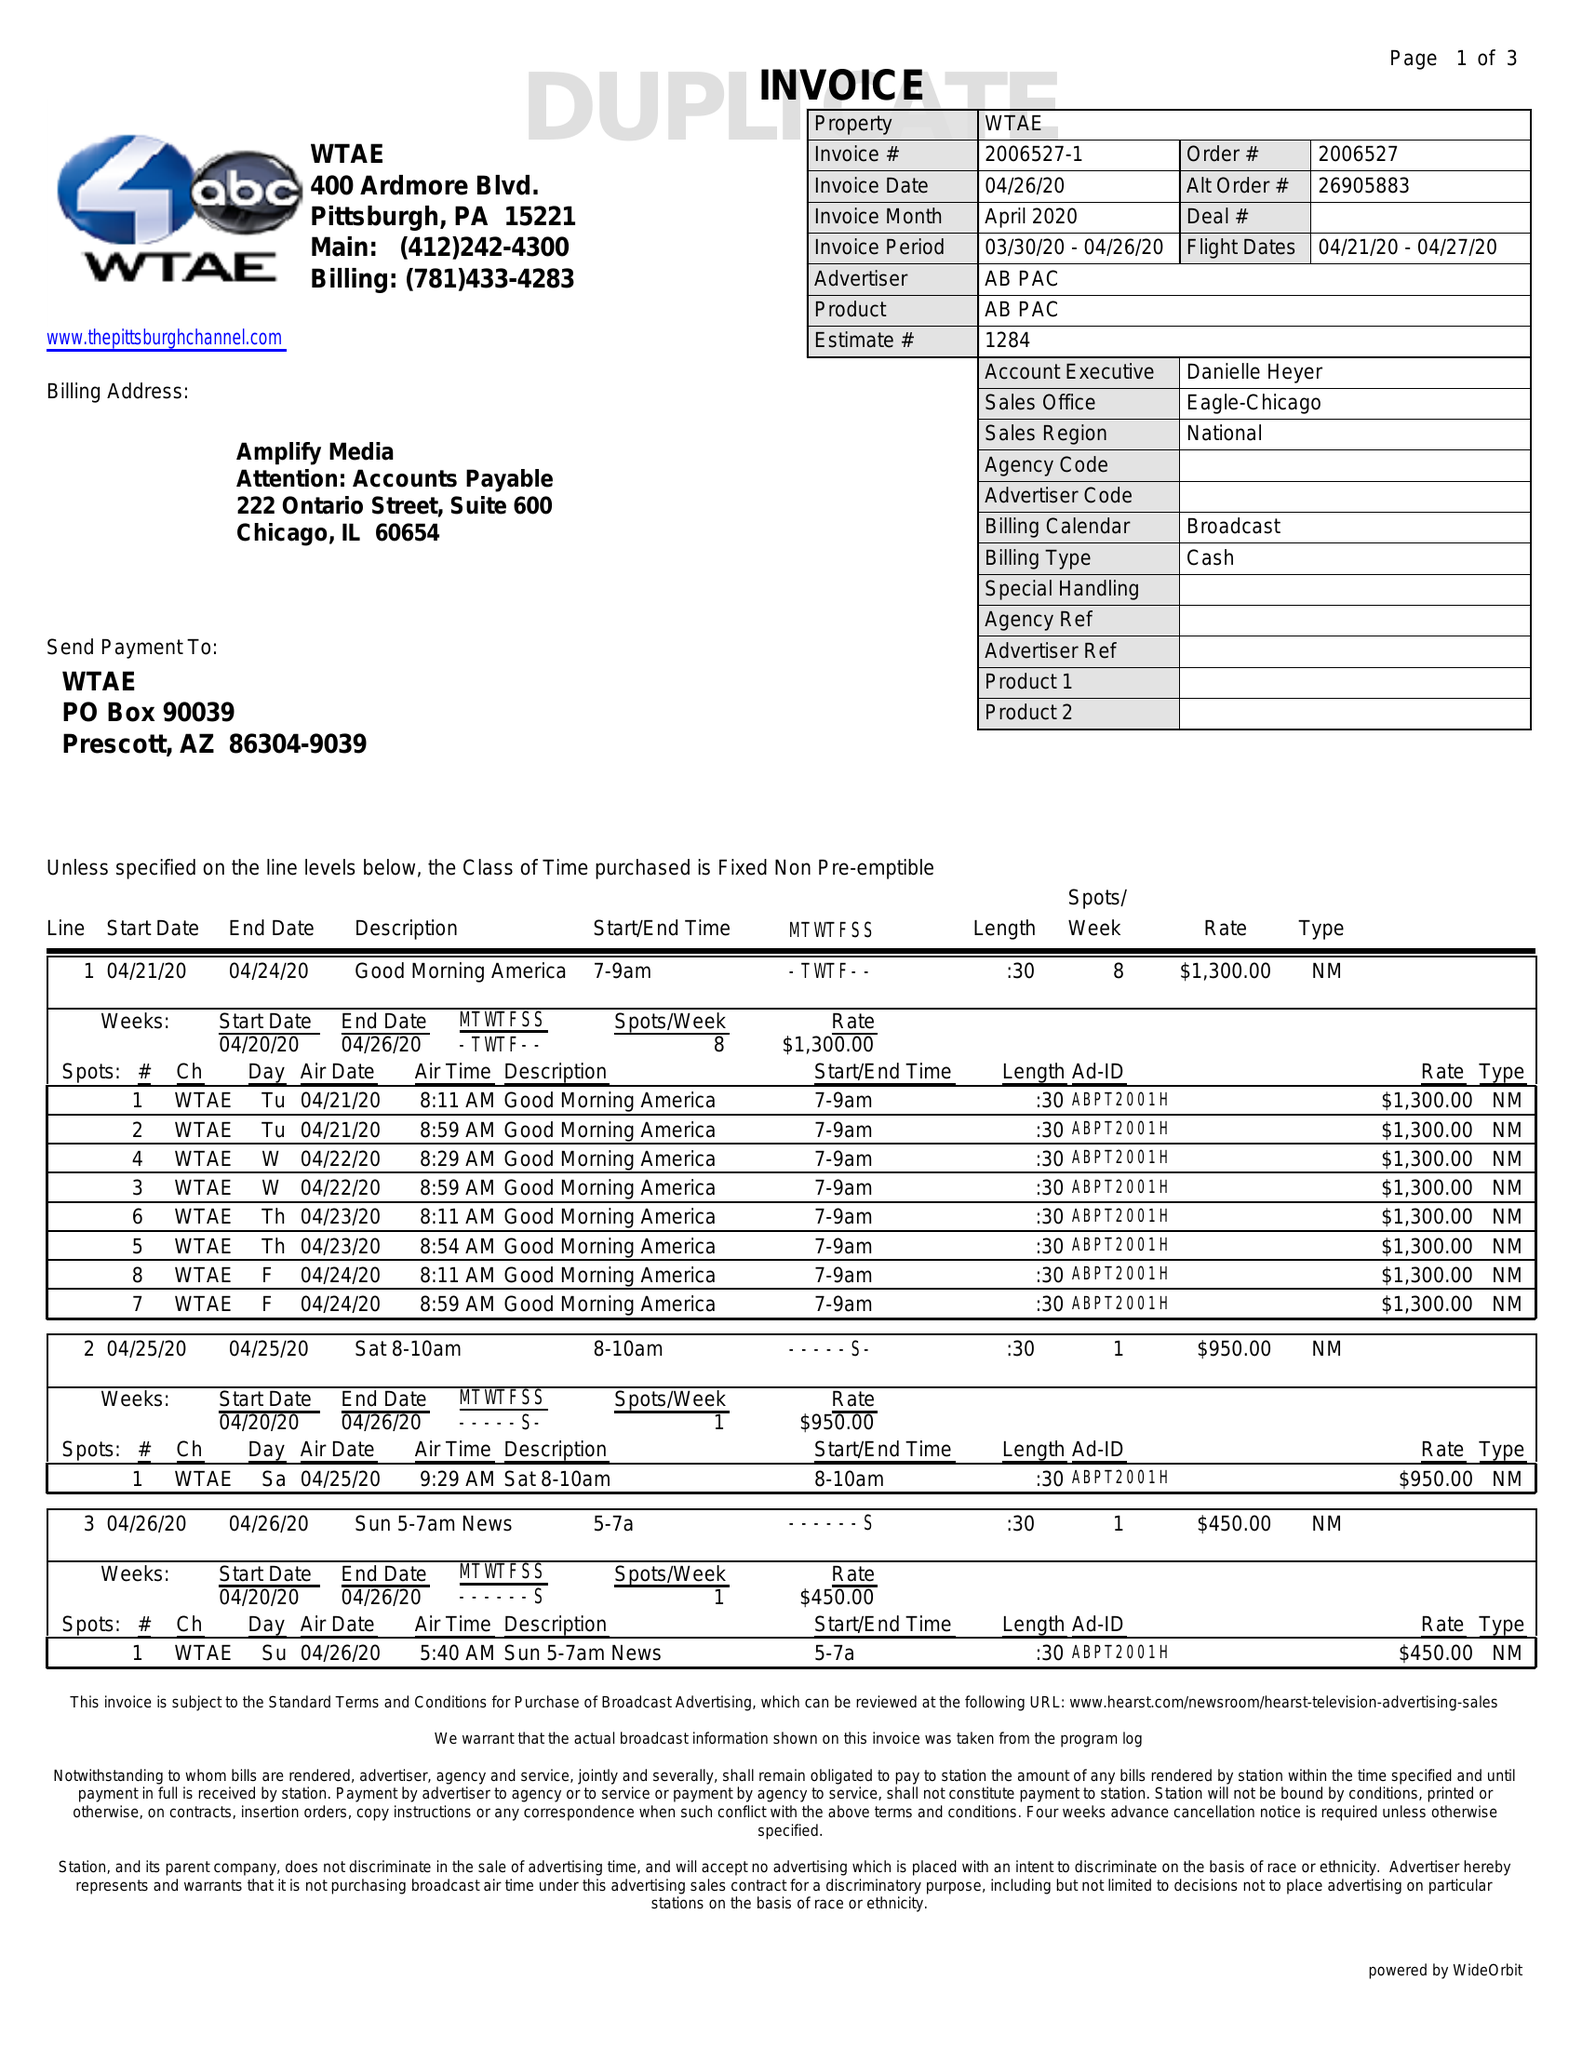What is the value for the flight_from?
Answer the question using a single word or phrase. 04/21/20 